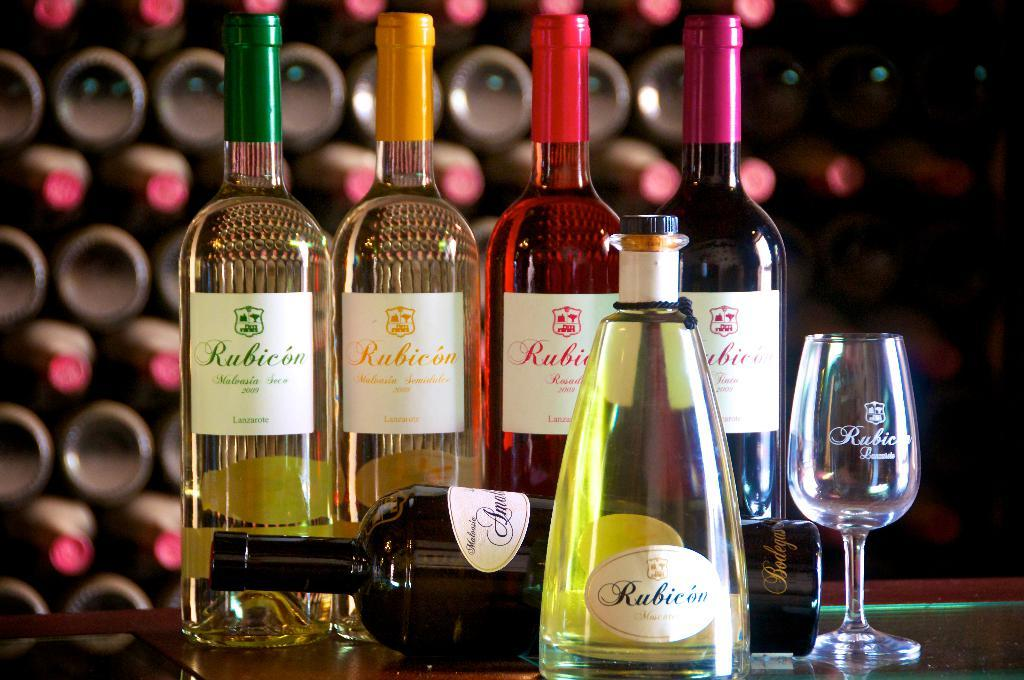Provide a one-sentence caption for the provided image. Several different colored bottles of wine from Rubicon are being displayed. 